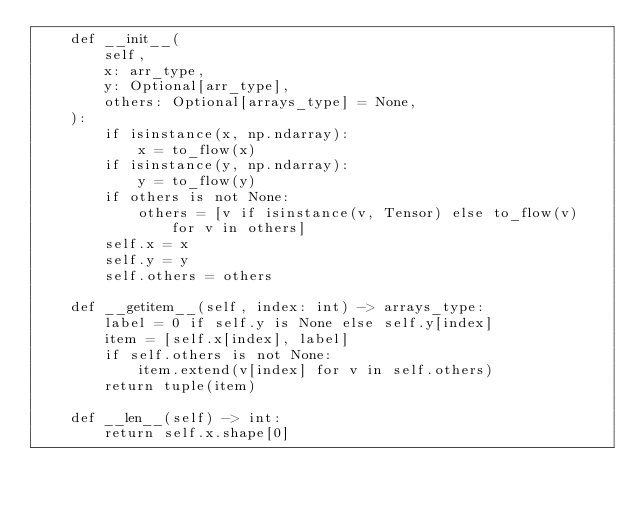<code> <loc_0><loc_0><loc_500><loc_500><_Python_>    def __init__(
        self,
        x: arr_type,
        y: Optional[arr_type],
        others: Optional[arrays_type] = None,
    ):
        if isinstance(x, np.ndarray):
            x = to_flow(x)
        if isinstance(y, np.ndarray):
            y = to_flow(y)
        if others is not None:
            others = [v if isinstance(v, Tensor) else to_flow(v) for v in others]
        self.x = x
        self.y = y
        self.others = others

    def __getitem__(self, index: int) -> arrays_type:
        label = 0 if self.y is None else self.y[index]
        item = [self.x[index], label]
        if self.others is not None:
            item.extend(v[index] for v in self.others)
        return tuple(item)

    def __len__(self) -> int:
        return self.x.shape[0]
</code> 